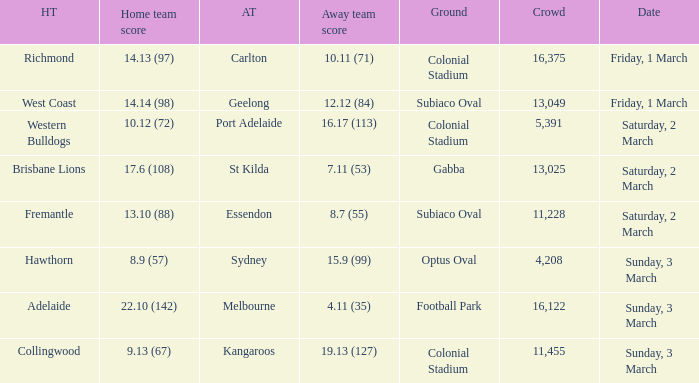What was the basis for the away team essendon? Subiaco Oval. 